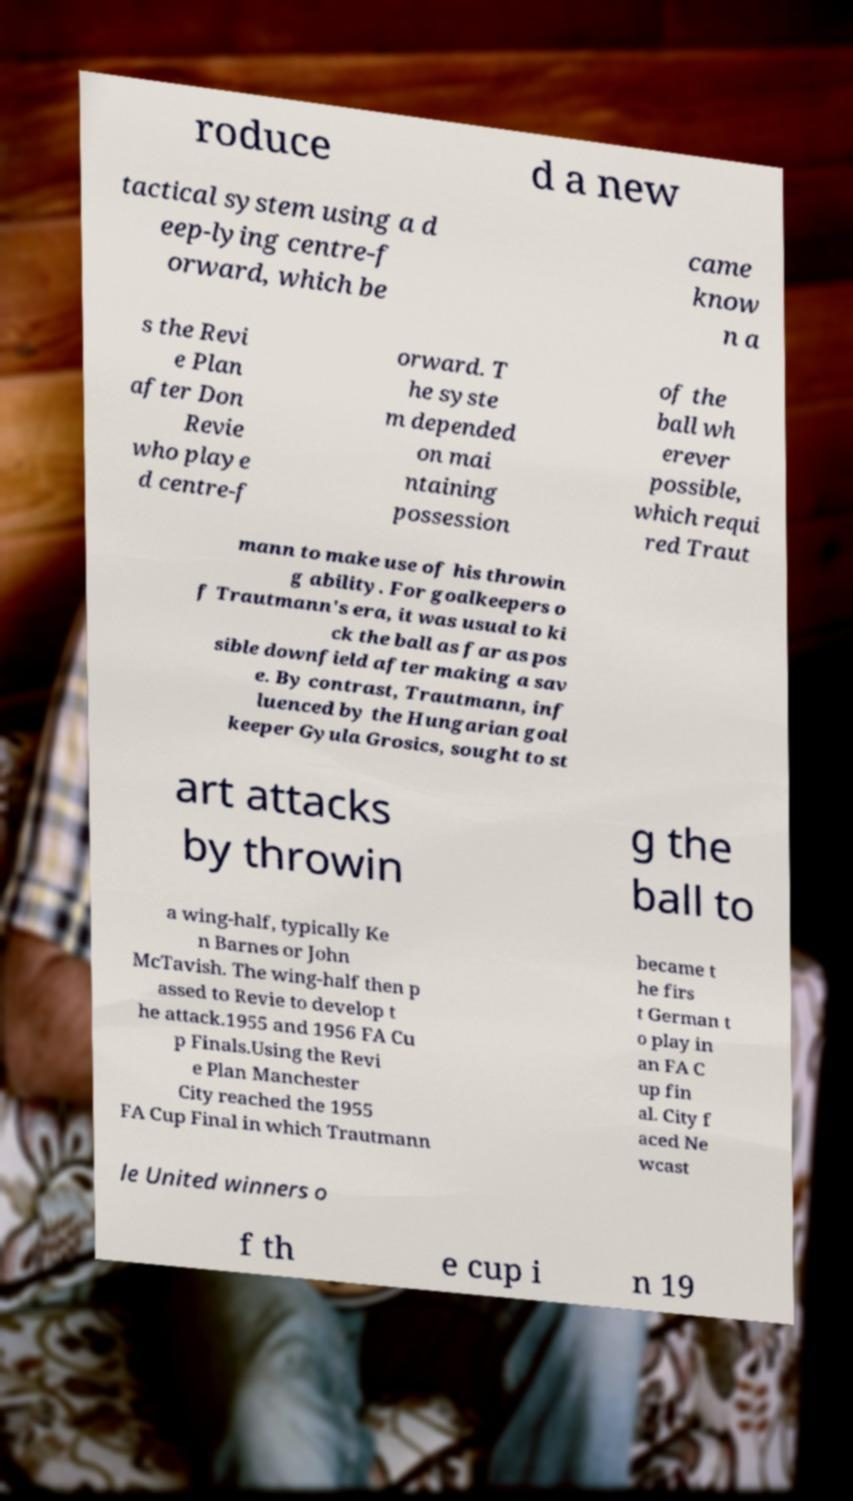Could you extract and type out the text from this image? roduce d a new tactical system using a d eep-lying centre-f orward, which be came know n a s the Revi e Plan after Don Revie who playe d centre-f orward. T he syste m depended on mai ntaining possession of the ball wh erever possible, which requi red Traut mann to make use of his throwin g ability. For goalkeepers o f Trautmann's era, it was usual to ki ck the ball as far as pos sible downfield after making a sav e. By contrast, Trautmann, inf luenced by the Hungarian goal keeper Gyula Grosics, sought to st art attacks by throwin g the ball to a wing-half, typically Ke n Barnes or John McTavish. The wing-half then p assed to Revie to develop t he attack.1955 and 1956 FA Cu p Finals.Using the Revi e Plan Manchester City reached the 1955 FA Cup Final in which Trautmann became t he firs t German t o play in an FA C up fin al. City f aced Ne wcast le United winners o f th e cup i n 19 